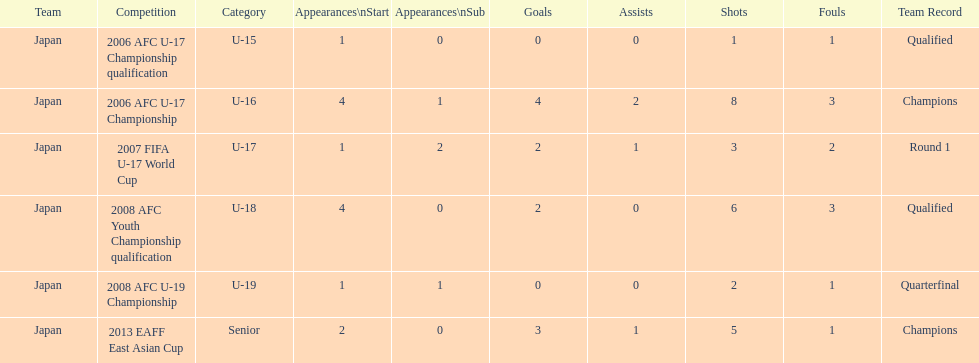Could you parse the entire table? {'header': ['Team', 'Competition', 'Category', 'Appearances\\nStart', 'Appearances\\nSub', 'Goals', 'Assists', 'Shots', 'Fouls', 'Team Record'], 'rows': [['Japan', '2006 AFC U-17 Championship qualification', 'U-15', '1', '0', '0', '0', '1', '1', 'Qualified'], ['Japan', '2006 AFC U-17 Championship', 'U-16', '4', '1', '4', '2', '8', '3', 'Champions'], ['Japan', '2007 FIFA U-17 World Cup', 'U-17', '1', '2', '2', '1', '3', '2', 'Round 1'], ['Japan', '2008 AFC Youth Championship qualification', 'U-18', '4', '0', '2', '0', '6', '3', 'Qualified'], ['Japan', '2008 AFC U-19 Championship', 'U-19', '1', '1', '0', '0', '2', '1', 'Quarterfinal'], ['Japan', '2013 EAFF East Asian Cup', 'Senior', '2', '0', '3', '1', '5', '1', 'Champions']]} Did japan have more starting appearances in the 2013 eaff east asian cup or 2007 fifa u-17 world cup? 2013 EAFF East Asian Cup. 